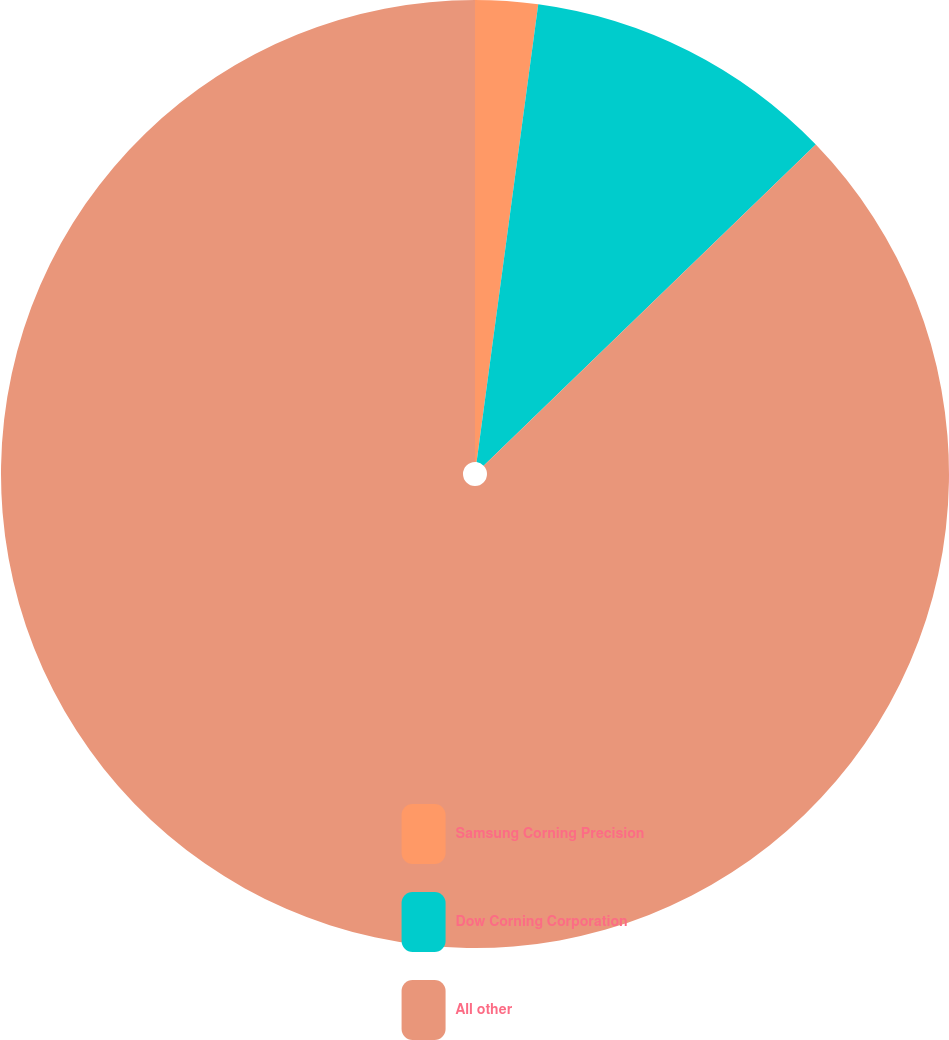<chart> <loc_0><loc_0><loc_500><loc_500><pie_chart><fcel>Samsung Corning Precision<fcel>Dow Corning Corporation<fcel>All other<nl><fcel>2.13%<fcel>10.64%<fcel>87.23%<nl></chart> 